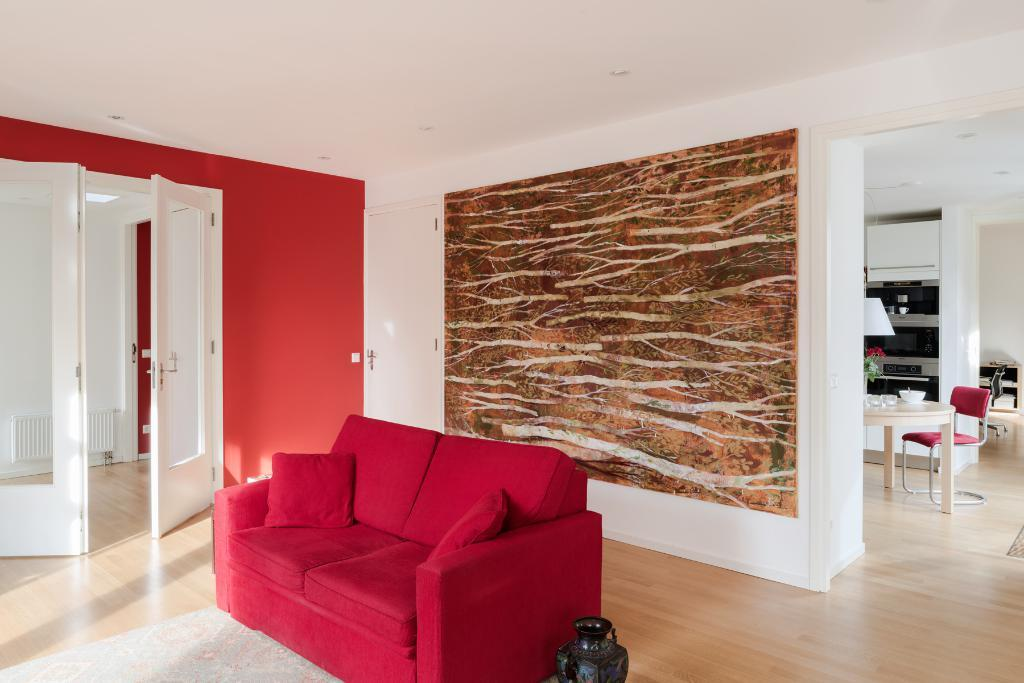What type of furniture is in the image? There is a red couch in the image. What is another object visible in the image? There is a door in the image. What decorative item can be seen in the image? There is a vase in the image. What can be seen in the background of the image? There is a wall visible in the background of the image, along with a chair near a table and items on the table. What type of equipment is visible in the background of the image? There are equipment visible in the background of the image. How many buttons are on the red couch in the image? There is no mention of buttons on the red couch in the image. What color are the toes of the person sitting on the red couch? There is no person sitting on the red couch in the image. Is there a wristwatch visible on the person's wrist near the table? There is no person or wristwatch visible in the image. 